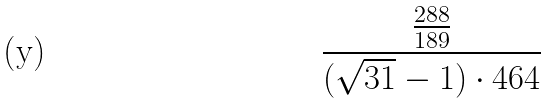Convert formula to latex. <formula><loc_0><loc_0><loc_500><loc_500>\frac { \frac { 2 8 8 } { 1 8 9 } } { ( \sqrt { 3 1 } - 1 ) \cdot 4 6 4 }</formula> 